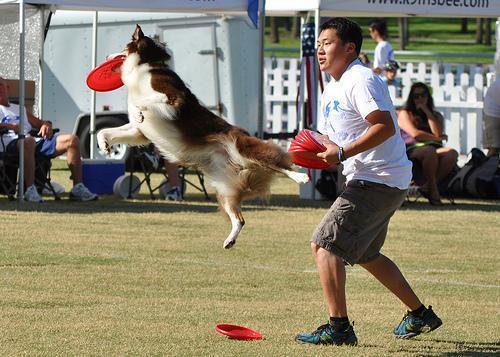How many dogs are there?
Give a very brief answer. 1. 